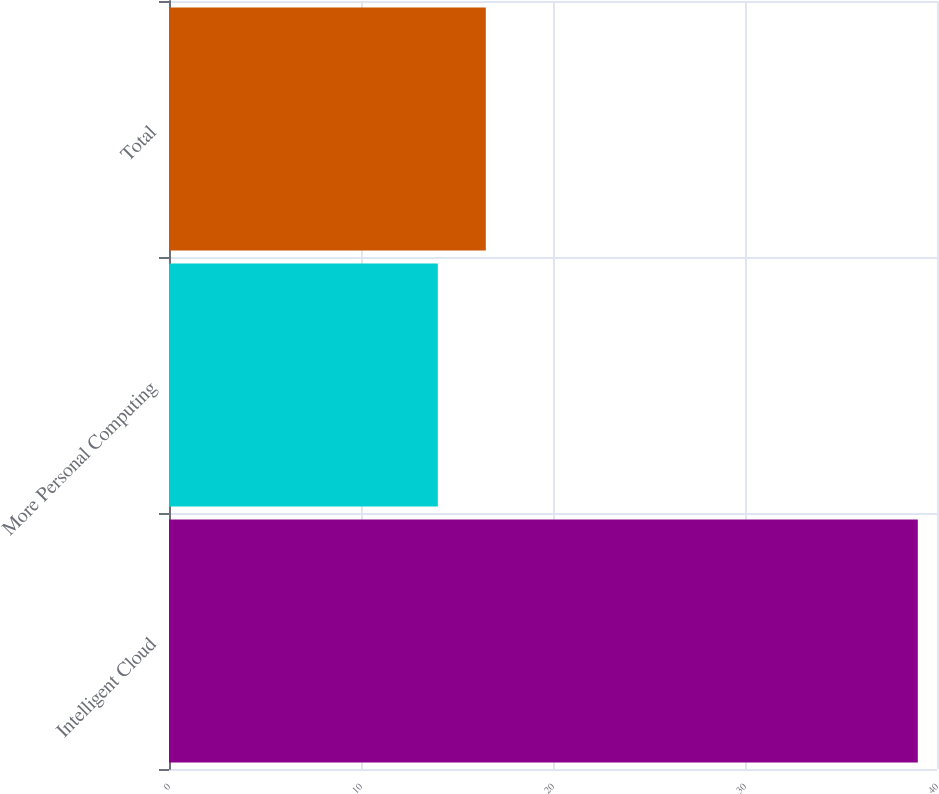Convert chart to OTSL. <chart><loc_0><loc_0><loc_500><loc_500><bar_chart><fcel>Intelligent Cloud<fcel>More Personal Computing<fcel>Total<nl><fcel>39<fcel>14<fcel>16.5<nl></chart> 